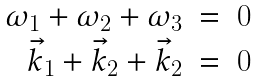Convert formula to latex. <formula><loc_0><loc_0><loc_500><loc_500>\begin{array} { r c l } \omega _ { 1 } + \omega _ { 2 } + \omega _ { 3 } & = & 0 \\ \vec { k } _ { 1 } + \vec { k } _ { 2 } + \vec { k } _ { 2 } & = & 0 \end{array}</formula> 